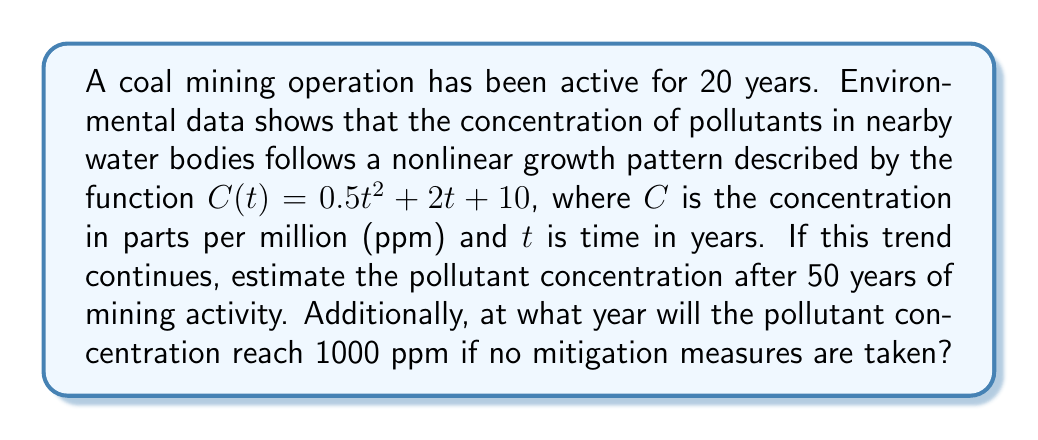Show me your answer to this math problem. To solve this problem, we'll follow these steps:

1. Calculate the pollutant concentration after 50 years:
   
   We use the given function $C(t) = 0.5t^2 + 2t + 10$ and substitute $t = 50$:
   
   $C(50) = 0.5(50)^2 + 2(50) + 10$
   $= 0.5(2500) + 100 + 10$
   $= 1250 + 100 + 10$
   $= 1360$ ppm

2. Find the year when pollutant concentration reaches 1000 ppm:
   
   We need to solve the equation:
   
   $1000 = 0.5t^2 + 2t + 10$
   
   Rearranging the equation:
   
   $0.5t^2 + 2t - 990 = 0$
   
   This is a quadratic equation in the form $at^2 + bt + c = 0$, where:
   $a = 0.5$, $b = 2$, and $c = -990$
   
   We can solve this using the quadratic formula: $t = \frac{-b \pm \sqrt{b^2 - 4ac}}{2a}$
   
   $t = \frac{-2 \pm \sqrt{2^2 - 4(0.5)(-990)}}{2(0.5)}$
   
   $= \frac{-2 \pm \sqrt{4 + 1980}}{1}$
   
   $= \frac{-2 \pm \sqrt{1984}}{1}$
   
   $= -2 \pm 44.54$
   
   This gives us two solutions: $t ≈ 42.54$ or $t ≈ -44.54$
   
   Since time cannot be negative in this context, we take the positive solution.

   Therefore, the pollutant concentration will reach 1000 ppm after approximately 42.54 years.
Answer: 1360 ppm after 50 years; 1000 ppm reached after 42.54 years 